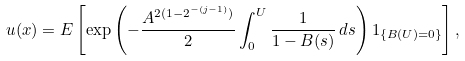<formula> <loc_0><loc_0><loc_500><loc_500>u ( x ) = E \left [ \exp \left ( - \frac { A ^ { 2 ( 1 - 2 ^ { - ( j - 1 ) } ) } } { 2 } \int _ { 0 } ^ { U } \frac { 1 } { 1 - B ( s ) } \, d s \right ) { 1 } _ { \{ B ( U ) = 0 \} } \right ] ,</formula> 